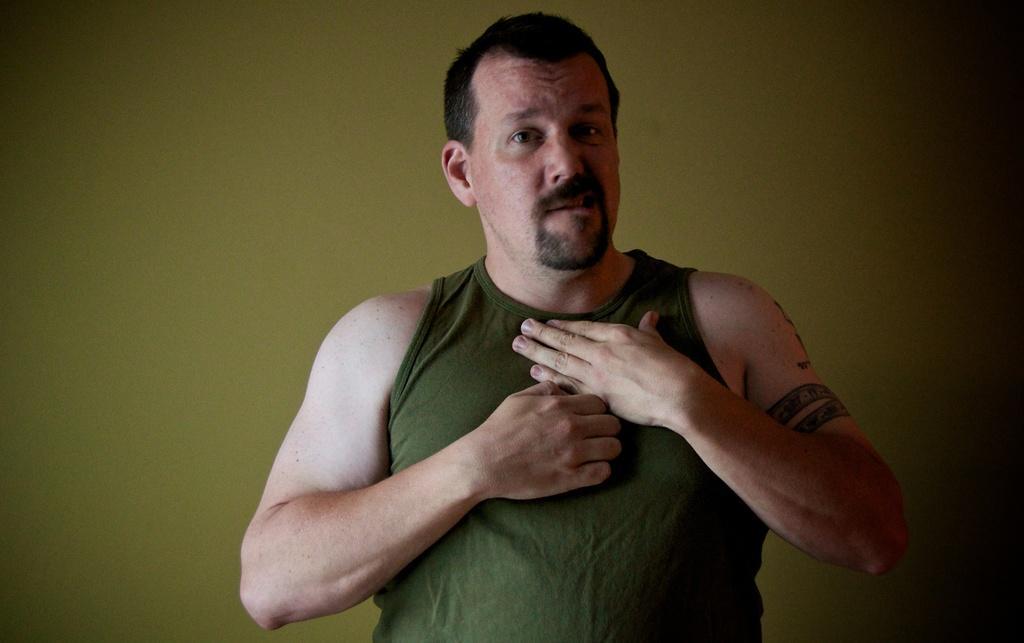In one or two sentences, can you explain what this image depicts? There is one person standing and wearing a gray color top in the middle of this image , and there is a green color wall in the background. 